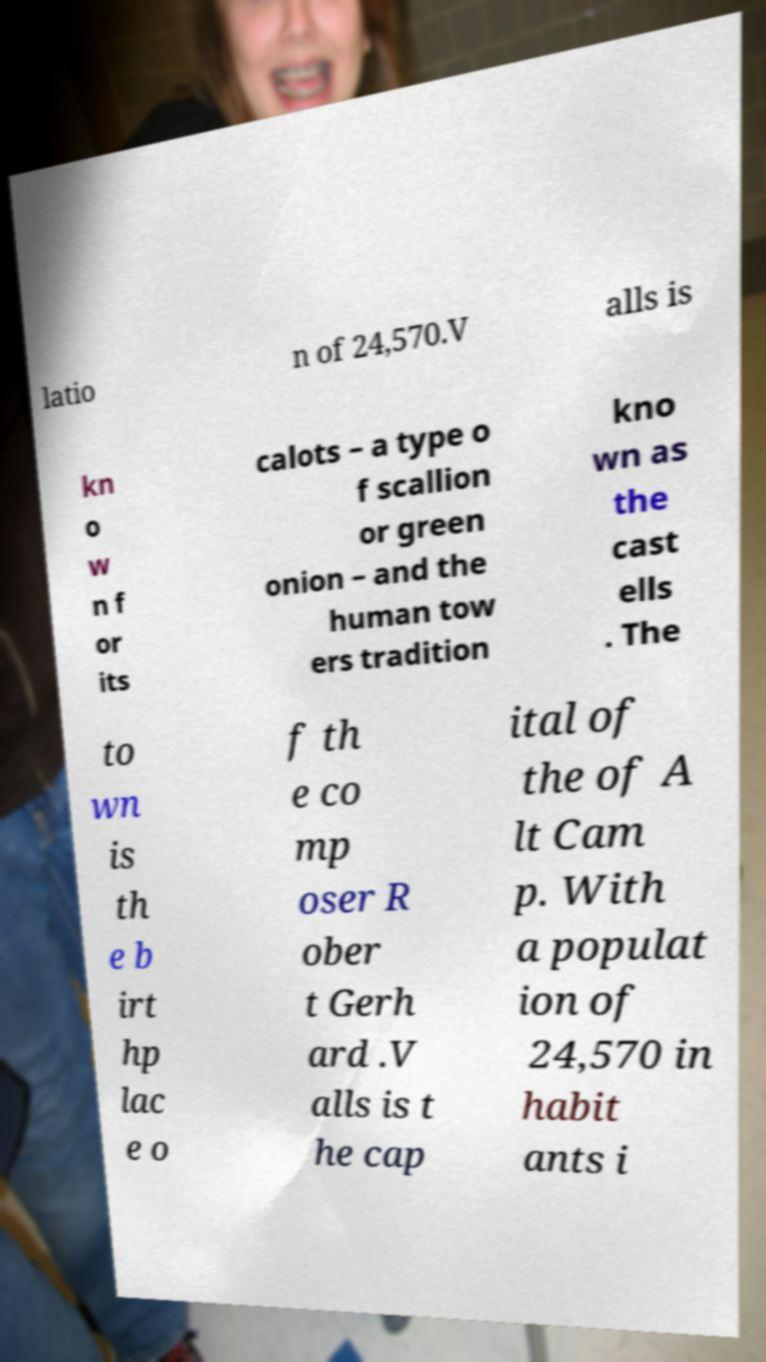Can you accurately transcribe the text from the provided image for me? latio n of 24,570.V alls is kn o w n f or its calots – a type o f scallion or green onion – and the human tow ers tradition kno wn as the cast ells . The to wn is th e b irt hp lac e o f th e co mp oser R ober t Gerh ard .V alls is t he cap ital of the of A lt Cam p. With a populat ion of 24,570 in habit ants i 